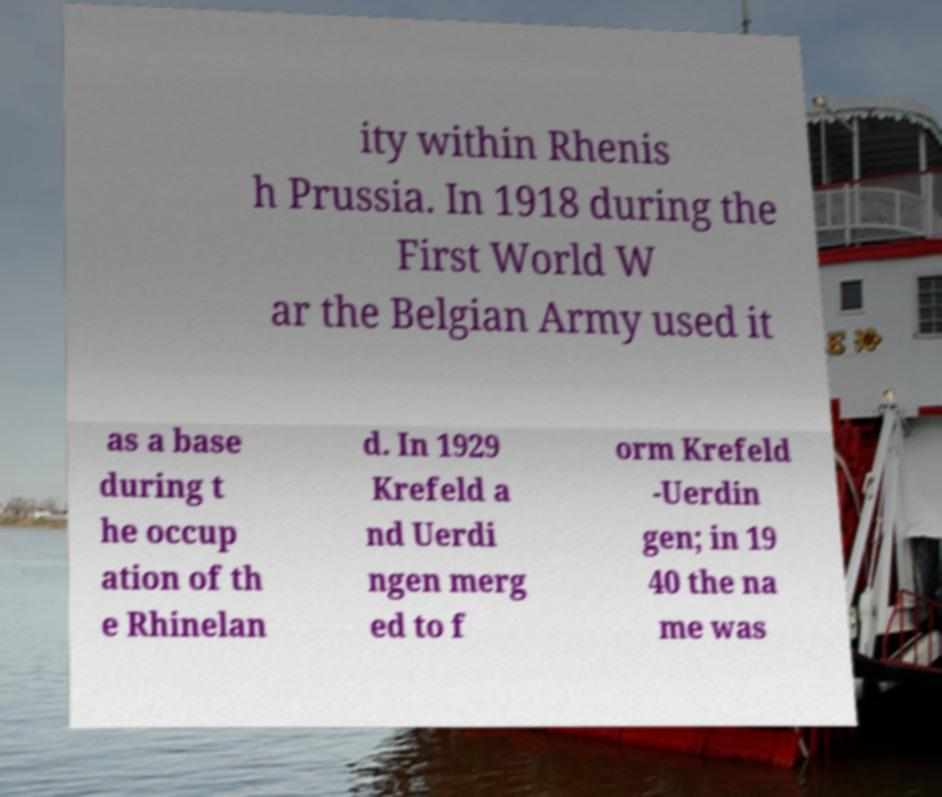There's text embedded in this image that I need extracted. Can you transcribe it verbatim? ity within Rhenis h Prussia. In 1918 during the First World W ar the Belgian Army used it as a base during t he occup ation of th e Rhinelan d. In 1929 Krefeld a nd Uerdi ngen merg ed to f orm Krefeld -Uerdin gen; in 19 40 the na me was 